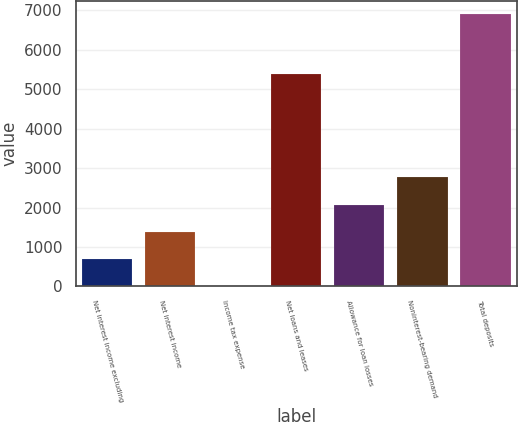<chart> <loc_0><loc_0><loc_500><loc_500><bar_chart><fcel>Net interest income excluding<fcel>Net interest income<fcel>Income tax expense<fcel>Net loans and leases<fcel>Allowance for loan losses<fcel>Noninterest-bearing demand<fcel>Total deposits<nl><fcel>693.47<fcel>1383.64<fcel>3.3<fcel>5389<fcel>2073.81<fcel>2763.98<fcel>6905<nl></chart> 